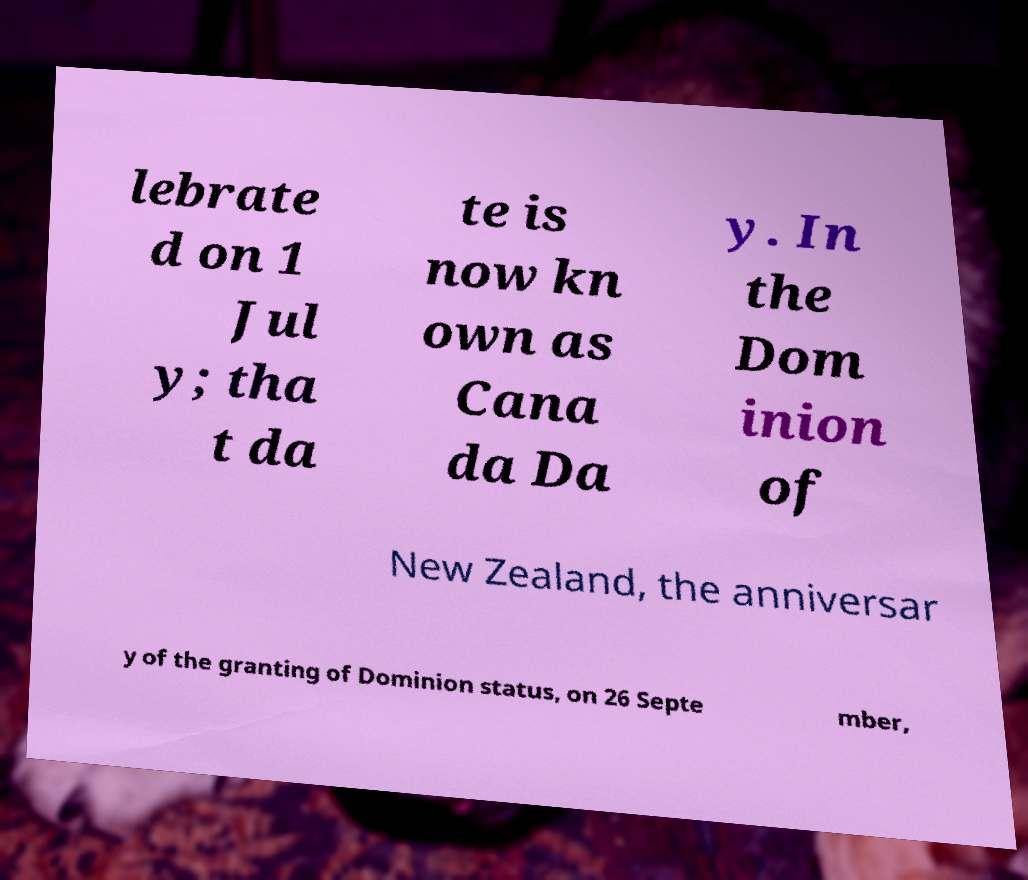Please read and relay the text visible in this image. What does it say? lebrate d on 1 Jul y; tha t da te is now kn own as Cana da Da y. In the Dom inion of New Zealand, the anniversar y of the granting of Dominion status, on 26 Septe mber, 